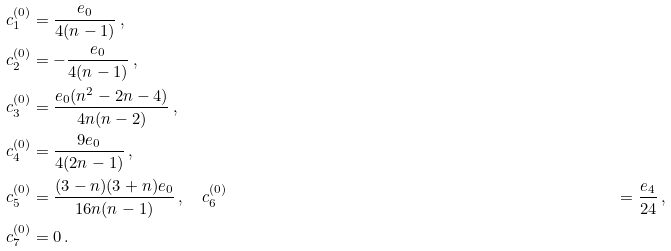Convert formula to latex. <formula><loc_0><loc_0><loc_500><loc_500>c ^ { ( 0 ) } _ { 1 } & = \frac { e _ { 0 } } { 4 ( n - 1 ) } \, , \\ c ^ { ( 0 ) } _ { 2 } & = - \frac { e _ { 0 } } { 4 ( n - 1 ) } \, , \\ c ^ { ( 0 ) } _ { 3 } & = \frac { e _ { 0 } ( n ^ { 2 } - 2 n - 4 ) } { 4 n ( n - 2 ) } \, , \\ c ^ { ( 0 ) } _ { 4 } & = \frac { 9 e _ { 0 } } { 4 ( 2 n - 1 ) } \, , \\ c ^ { ( 0 ) } _ { 5 } & = \frac { ( 3 - n ) ( 3 + n ) e _ { 0 } } { 1 6 n ( n - 1 ) } \, , \quad c ^ { ( 0 ) } _ { 6 } & = \frac { e _ { 4 } } { 2 4 } \, , \\ c ^ { ( 0 ) } _ { 7 } & = 0 \, .</formula> 